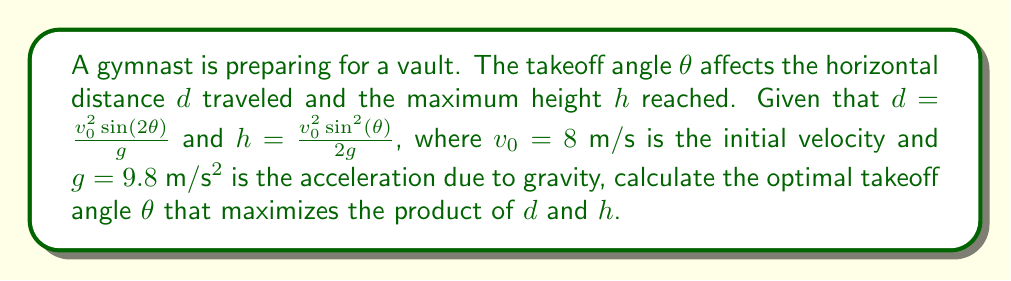Can you answer this question? 1) We need to maximize the product of d and h. Let's call this product P:
   $$P = d \cdot h = \frac{v_0^2\sin(2\theta)}{g} \cdot \frac{v_0^2\sin^2(\theta)}{2g}$$

2) Simplify using the identity sin(2θ) = 2sin(θ)cos(θ):
   $$P = \frac{v_0^4}{2g^2} \cdot 2\sin^3(\theta)\cos(\theta)$$

3) To find the maximum, we differentiate P with respect to θ and set it to zero:
   $$\frac{dP}{d\theta} = \frac{v_0^4}{g^2} \cdot (6\sin^2(\theta)\cos^2(\theta) - 2\sin^4(\theta)) = 0$$

4) Factor out common terms:
   $$2\sin^2(\theta)(3\cos^2(\theta) - \sin^2(\theta)) = 0$$

5) Solve the equation:
   Either $\sin^2(\theta) = 0$ (which gives θ = 0° or 180°, not optimal)
   Or $3\cos^2(\theta) - \sin^2(\theta) = 0$

6) Using the identity $\cos^2(\theta) + \sin^2(\theta) = 1$, we can write:
   $$3(1 - \sin^2(\theta)) - \sin^2(\theta) = 0$$
   $$3 - 3\sin^2(\theta) - \sin^2(\theta) = 0$$
   $$3 - 4\sin^2(\theta) = 0$$
   $$\sin^2(\theta) = \frac{3}{4}$$

7) Taking the square root:
   $$\sin(\theta) = \frac{\sqrt{3}}{2}$$

8) This corresponds to:
   $$\theta = \arcsin(\frac{\sqrt{3}}{2}) = 60°$$
Answer: 60° 